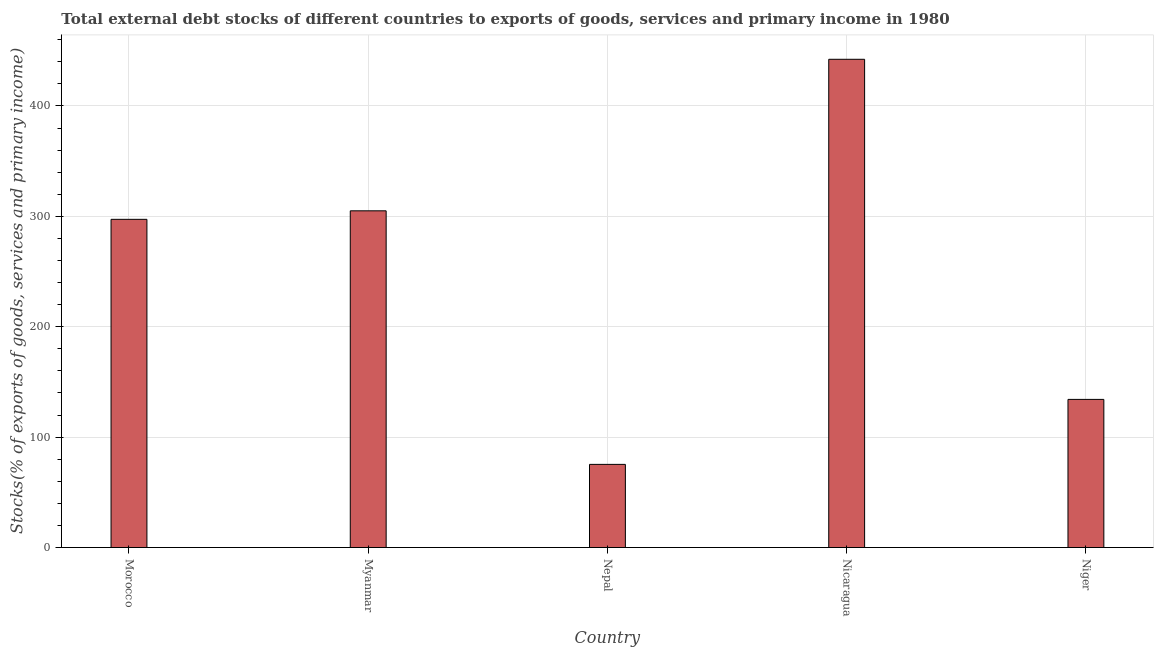Does the graph contain any zero values?
Offer a very short reply. No. Does the graph contain grids?
Your answer should be very brief. Yes. What is the title of the graph?
Your answer should be compact. Total external debt stocks of different countries to exports of goods, services and primary income in 1980. What is the label or title of the Y-axis?
Make the answer very short. Stocks(% of exports of goods, services and primary income). What is the external debt stocks in Nepal?
Keep it short and to the point. 75.31. Across all countries, what is the maximum external debt stocks?
Give a very brief answer. 442.25. Across all countries, what is the minimum external debt stocks?
Provide a short and direct response. 75.31. In which country was the external debt stocks maximum?
Your response must be concise. Nicaragua. In which country was the external debt stocks minimum?
Ensure brevity in your answer.  Nepal. What is the sum of the external debt stocks?
Provide a short and direct response. 1254.01. What is the difference between the external debt stocks in Myanmar and Nicaragua?
Your answer should be very brief. -137.27. What is the average external debt stocks per country?
Offer a terse response. 250.8. What is the median external debt stocks?
Provide a succinct answer. 297.28. What is the ratio of the external debt stocks in Nepal to that in Nicaragua?
Keep it short and to the point. 0.17. What is the difference between the highest and the second highest external debt stocks?
Provide a succinct answer. 137.27. Is the sum of the external debt stocks in Nepal and Nicaragua greater than the maximum external debt stocks across all countries?
Offer a very short reply. Yes. What is the difference between the highest and the lowest external debt stocks?
Keep it short and to the point. 366.94. In how many countries, is the external debt stocks greater than the average external debt stocks taken over all countries?
Your answer should be very brief. 3. Are all the bars in the graph horizontal?
Give a very brief answer. No. What is the Stocks(% of exports of goods, services and primary income) of Morocco?
Make the answer very short. 297.28. What is the Stocks(% of exports of goods, services and primary income) of Myanmar?
Provide a short and direct response. 304.99. What is the Stocks(% of exports of goods, services and primary income) of Nepal?
Your answer should be very brief. 75.31. What is the Stocks(% of exports of goods, services and primary income) of Nicaragua?
Provide a short and direct response. 442.25. What is the Stocks(% of exports of goods, services and primary income) in Niger?
Your answer should be very brief. 134.18. What is the difference between the Stocks(% of exports of goods, services and primary income) in Morocco and Myanmar?
Your answer should be compact. -7.71. What is the difference between the Stocks(% of exports of goods, services and primary income) in Morocco and Nepal?
Ensure brevity in your answer.  221.96. What is the difference between the Stocks(% of exports of goods, services and primary income) in Morocco and Nicaragua?
Your response must be concise. -144.98. What is the difference between the Stocks(% of exports of goods, services and primary income) in Morocco and Niger?
Offer a terse response. 163.1. What is the difference between the Stocks(% of exports of goods, services and primary income) in Myanmar and Nepal?
Keep it short and to the point. 229.67. What is the difference between the Stocks(% of exports of goods, services and primary income) in Myanmar and Nicaragua?
Ensure brevity in your answer.  -137.27. What is the difference between the Stocks(% of exports of goods, services and primary income) in Myanmar and Niger?
Your answer should be compact. 170.81. What is the difference between the Stocks(% of exports of goods, services and primary income) in Nepal and Nicaragua?
Your answer should be very brief. -366.94. What is the difference between the Stocks(% of exports of goods, services and primary income) in Nepal and Niger?
Your answer should be very brief. -58.86. What is the difference between the Stocks(% of exports of goods, services and primary income) in Nicaragua and Niger?
Offer a terse response. 308.08. What is the ratio of the Stocks(% of exports of goods, services and primary income) in Morocco to that in Myanmar?
Offer a terse response. 0.97. What is the ratio of the Stocks(% of exports of goods, services and primary income) in Morocco to that in Nepal?
Offer a terse response. 3.95. What is the ratio of the Stocks(% of exports of goods, services and primary income) in Morocco to that in Nicaragua?
Provide a short and direct response. 0.67. What is the ratio of the Stocks(% of exports of goods, services and primary income) in Morocco to that in Niger?
Give a very brief answer. 2.22. What is the ratio of the Stocks(% of exports of goods, services and primary income) in Myanmar to that in Nepal?
Offer a very short reply. 4.05. What is the ratio of the Stocks(% of exports of goods, services and primary income) in Myanmar to that in Nicaragua?
Provide a succinct answer. 0.69. What is the ratio of the Stocks(% of exports of goods, services and primary income) in Myanmar to that in Niger?
Your response must be concise. 2.27. What is the ratio of the Stocks(% of exports of goods, services and primary income) in Nepal to that in Nicaragua?
Provide a short and direct response. 0.17. What is the ratio of the Stocks(% of exports of goods, services and primary income) in Nepal to that in Niger?
Provide a succinct answer. 0.56. What is the ratio of the Stocks(% of exports of goods, services and primary income) in Nicaragua to that in Niger?
Ensure brevity in your answer.  3.3. 